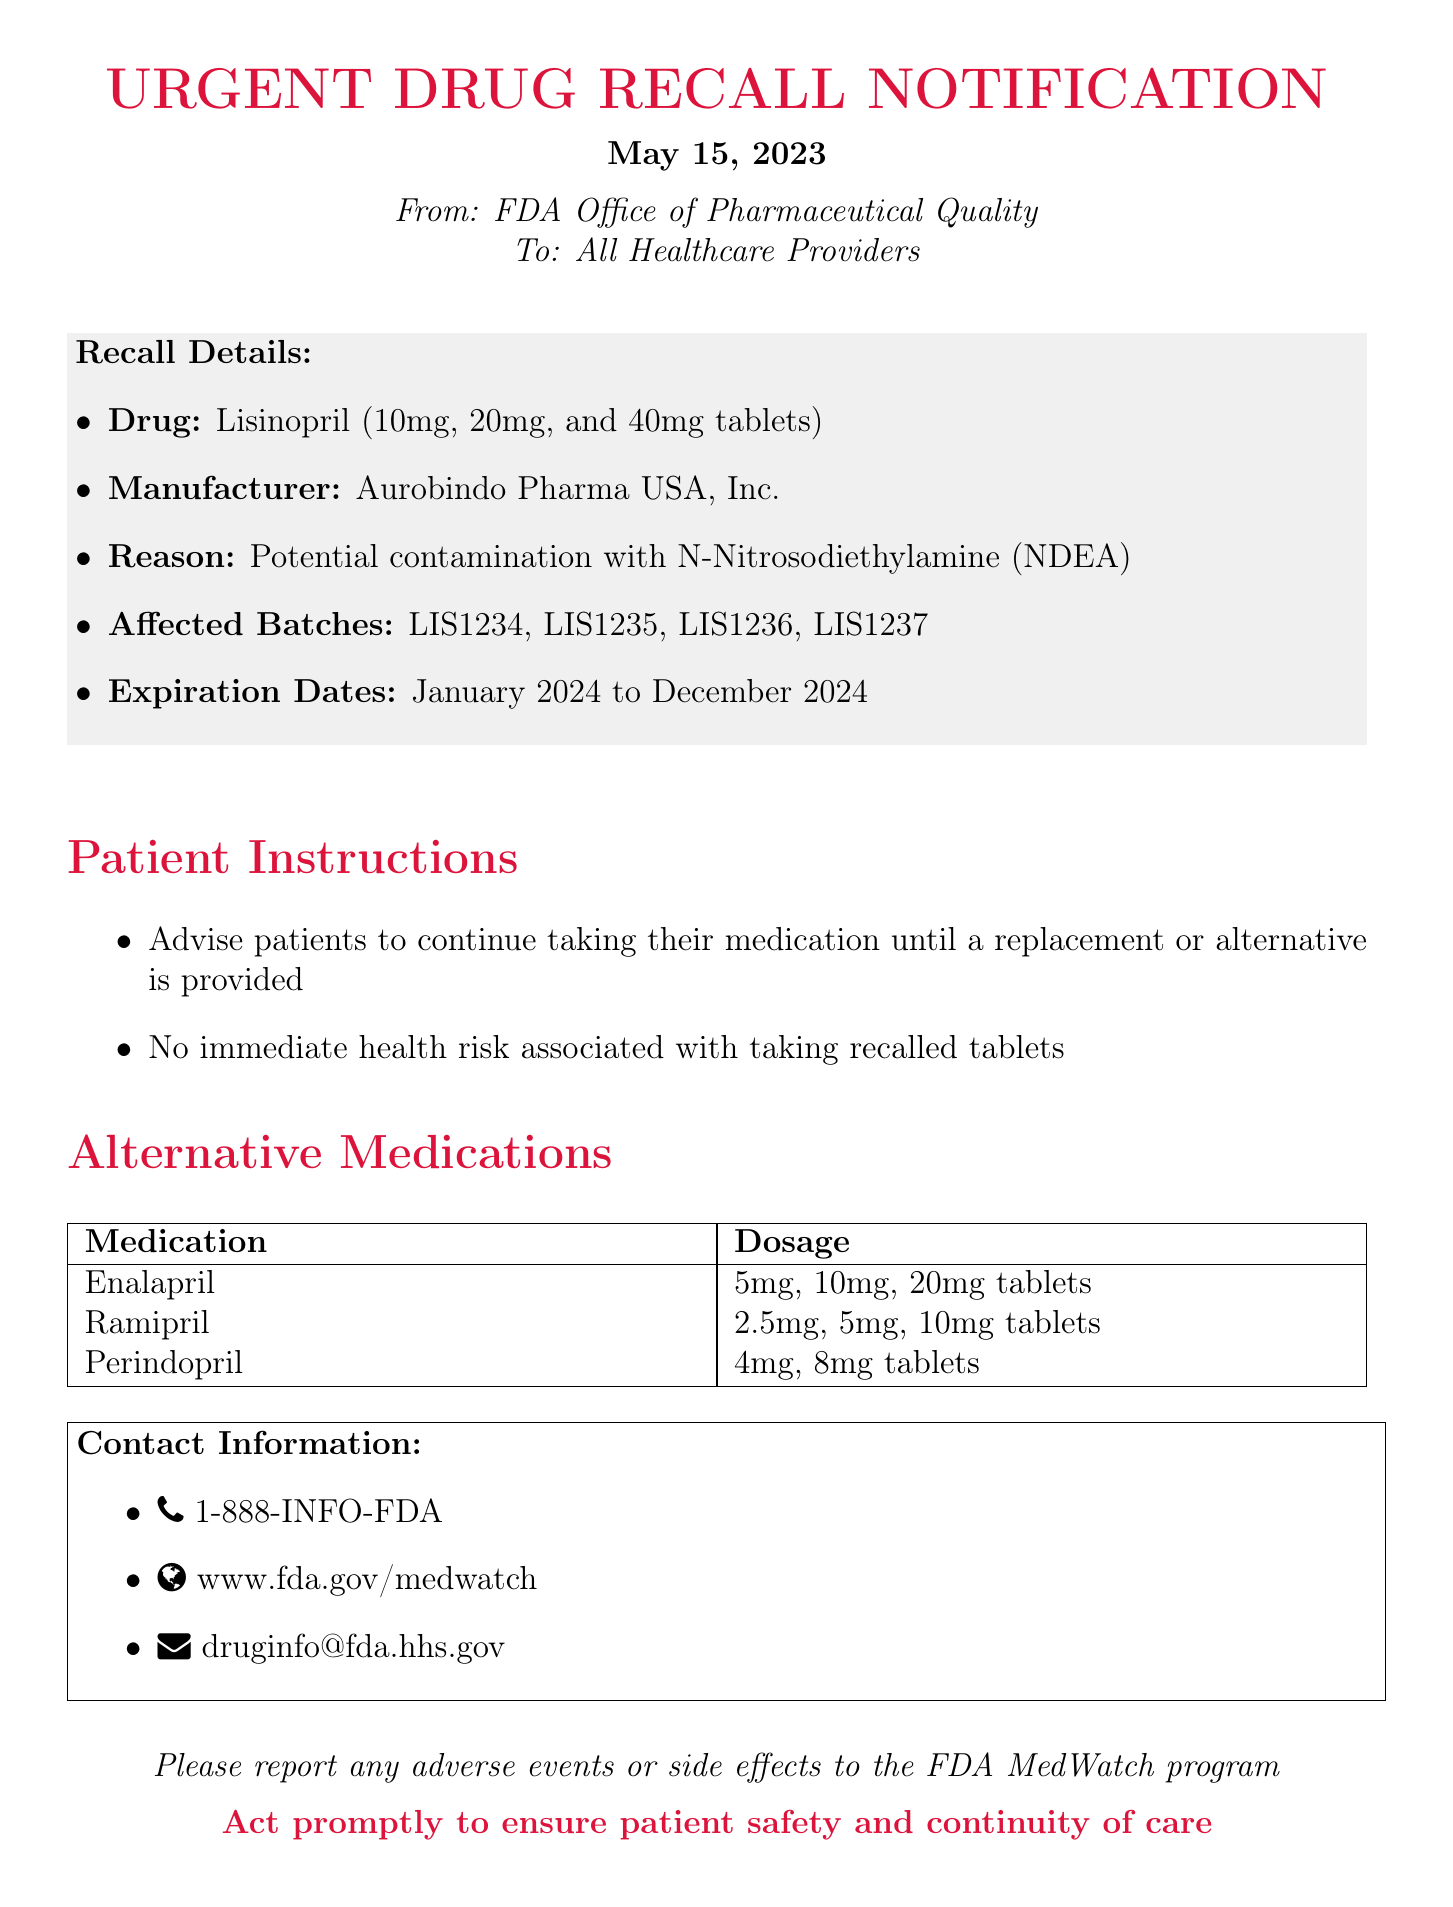what is the drug involved in the recall? The document explicitly lists the drug that is recalled as Lisinopril.
Answer: Lisinopril who is the manufacturer of the recalled drug? The manufacturer of the recalled drug is stated within the document as Aurobindo Pharma USA, Inc.
Answer: Aurobindo Pharma USA, Inc what are the affected batch numbers? The document provides a list of affected batch numbers including LIS1234, LIS1235, LIS1236, and LIS1237.
Answer: LIS1234, LIS1235, LIS1236, LIS1237 what is the reason for the recall? The document specifies that the reason for the recall is potential contamination with N-Nitrosodiethylamine (NDEA).
Answer: Potential contamination with N-Nitrosodiethylamine (NDEA) are there any immediate health risks associated with the recalled drug? The document states that there is no immediate health risk associated with taking the recalled tablets, answering this question directly.
Answer: No what instruction should patients follow regarding their medication? According to the document, patients should continue taking their medication until a replacement or alternative is provided.
Answer: Continue taking their medication until a replacement or alternative is provided what is one of the alternative medications suggested? The document lists a few alternative medications, one of which is Enalapril.
Answer: Enalapril what is the expiration date range of the affected batches? The document mentions that the expiration dates of the affected batches are from January 2024 to December 2024.
Answer: January 2024 to December 2024 